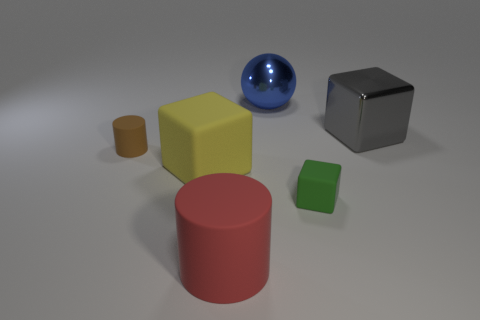Add 2 large metal blocks. How many objects exist? 8 Subtract all spheres. How many objects are left? 5 Add 5 small cylinders. How many small cylinders are left? 6 Add 6 large yellow rubber objects. How many large yellow rubber objects exist? 7 Subtract 1 blue spheres. How many objects are left? 5 Subtract all spheres. Subtract all large blue shiny objects. How many objects are left? 4 